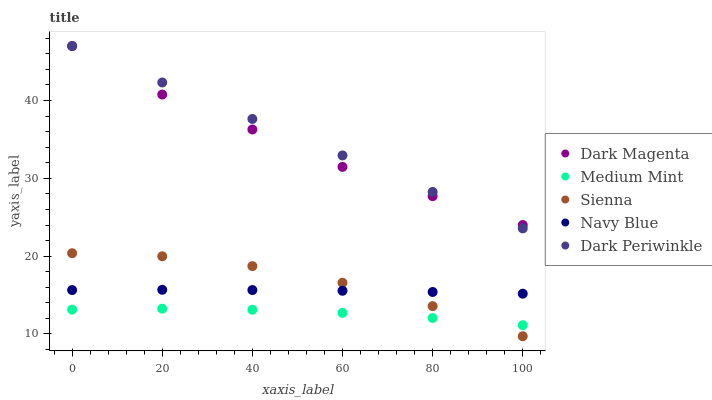Does Medium Mint have the minimum area under the curve?
Answer yes or no. Yes. Does Dark Periwinkle have the maximum area under the curve?
Answer yes or no. Yes. Does Sienna have the minimum area under the curve?
Answer yes or no. No. Does Sienna have the maximum area under the curve?
Answer yes or no. No. Is Dark Periwinkle the smoothest?
Answer yes or no. Yes. Is Sienna the roughest?
Answer yes or no. Yes. Is Sienna the smoothest?
Answer yes or no. No. Is Dark Periwinkle the roughest?
Answer yes or no. No. Does Sienna have the lowest value?
Answer yes or no. Yes. Does Dark Periwinkle have the lowest value?
Answer yes or no. No. Does Dark Magenta have the highest value?
Answer yes or no. Yes. Does Sienna have the highest value?
Answer yes or no. No. Is Navy Blue less than Dark Magenta?
Answer yes or no. Yes. Is Dark Magenta greater than Navy Blue?
Answer yes or no. Yes. Does Medium Mint intersect Sienna?
Answer yes or no. Yes. Is Medium Mint less than Sienna?
Answer yes or no. No. Is Medium Mint greater than Sienna?
Answer yes or no. No. Does Navy Blue intersect Dark Magenta?
Answer yes or no. No. 